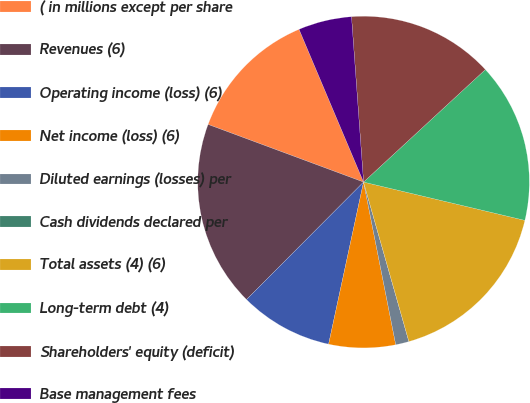<chart> <loc_0><loc_0><loc_500><loc_500><pie_chart><fcel>( in millions except per share<fcel>Revenues (6)<fcel>Operating income (loss) (6)<fcel>Net income (loss) (6)<fcel>Diluted earnings (losses) per<fcel>Cash dividends declared per<fcel>Total assets (4) (6)<fcel>Long-term debt (4)<fcel>Shareholders' equity (deficit)<fcel>Base management fees<nl><fcel>12.99%<fcel>18.18%<fcel>9.09%<fcel>6.49%<fcel>1.3%<fcel>0.0%<fcel>16.88%<fcel>15.58%<fcel>14.29%<fcel>5.2%<nl></chart> 